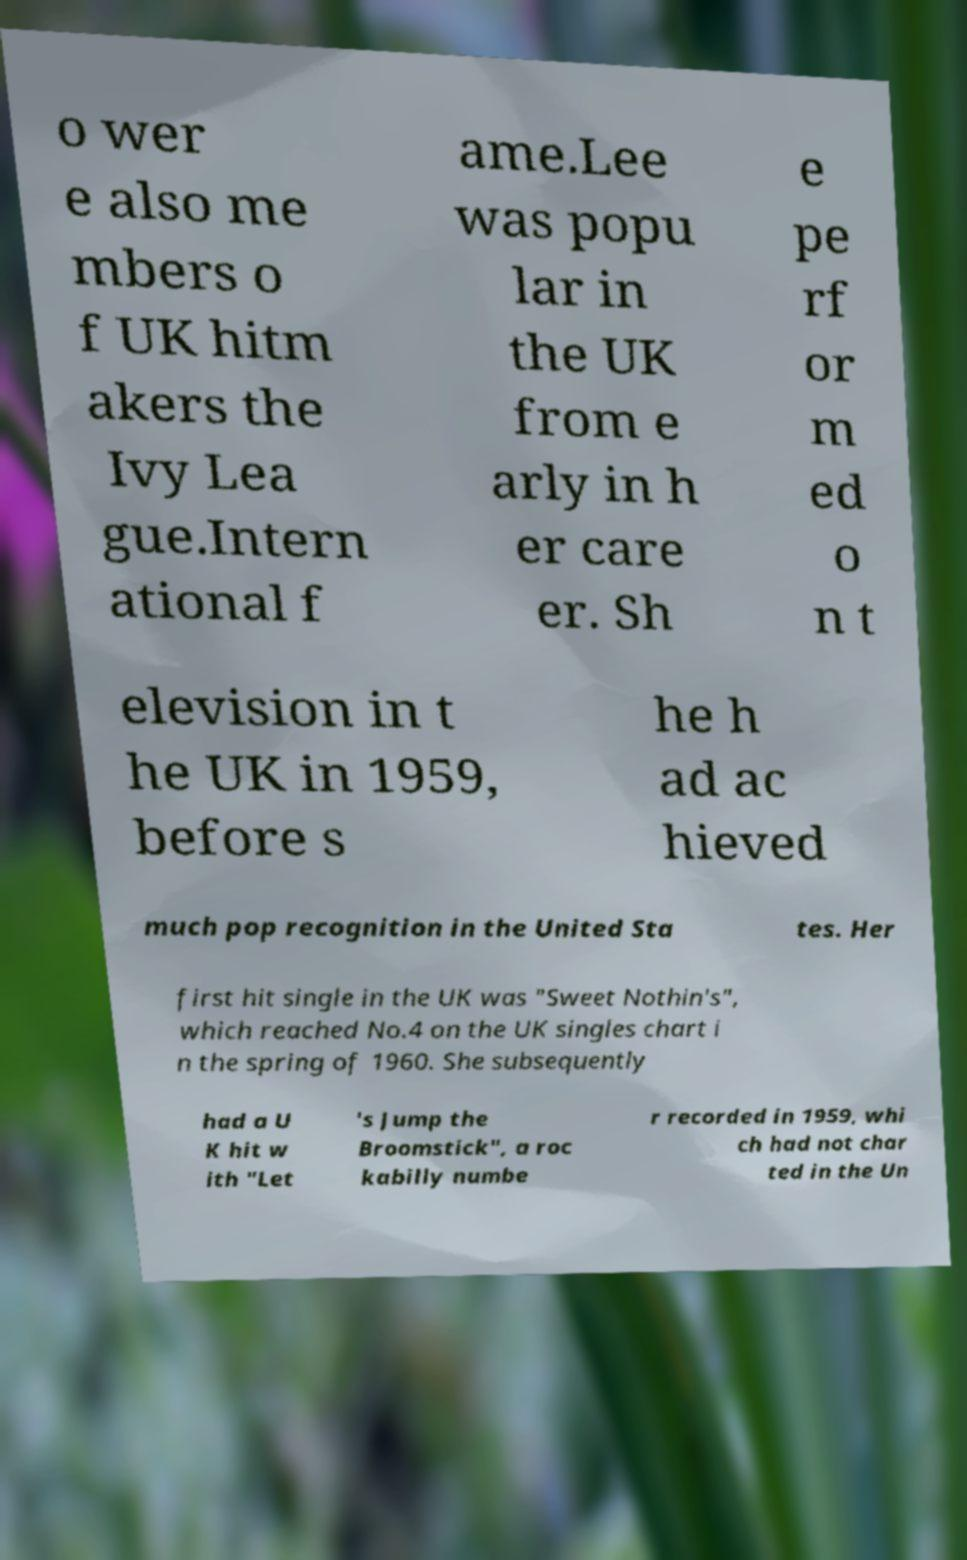For documentation purposes, I need the text within this image transcribed. Could you provide that? o wer e also me mbers o f UK hitm akers the Ivy Lea gue.Intern ational f ame.Lee was popu lar in the UK from e arly in h er care er. Sh e pe rf or m ed o n t elevision in t he UK in 1959, before s he h ad ac hieved much pop recognition in the United Sta tes. Her first hit single in the UK was "Sweet Nothin's", which reached No.4 on the UK singles chart i n the spring of 1960. She subsequently had a U K hit w ith "Let 's Jump the Broomstick", a roc kabilly numbe r recorded in 1959, whi ch had not char ted in the Un 